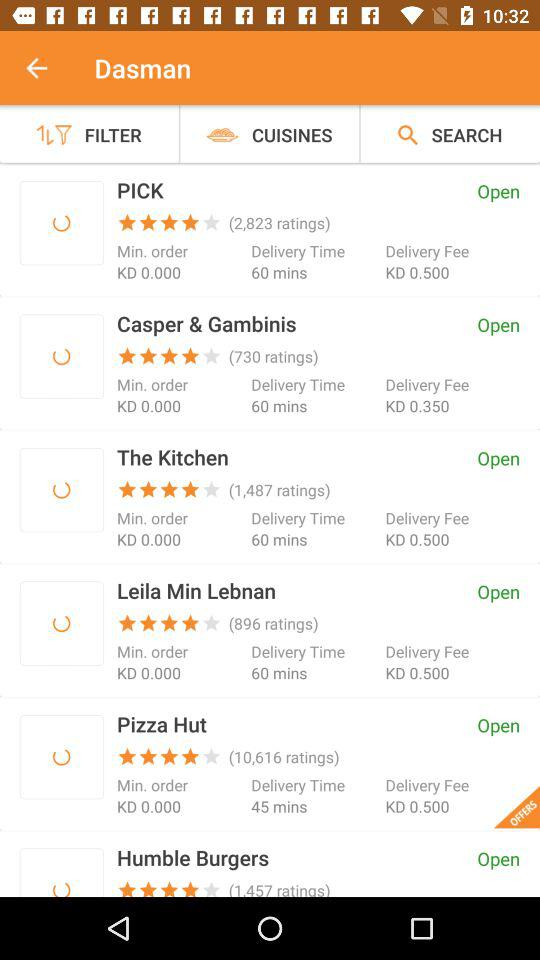Who takes 45 minutes for delivery? The one that takes 45 minutes for delivery is "Pizza Hut". 